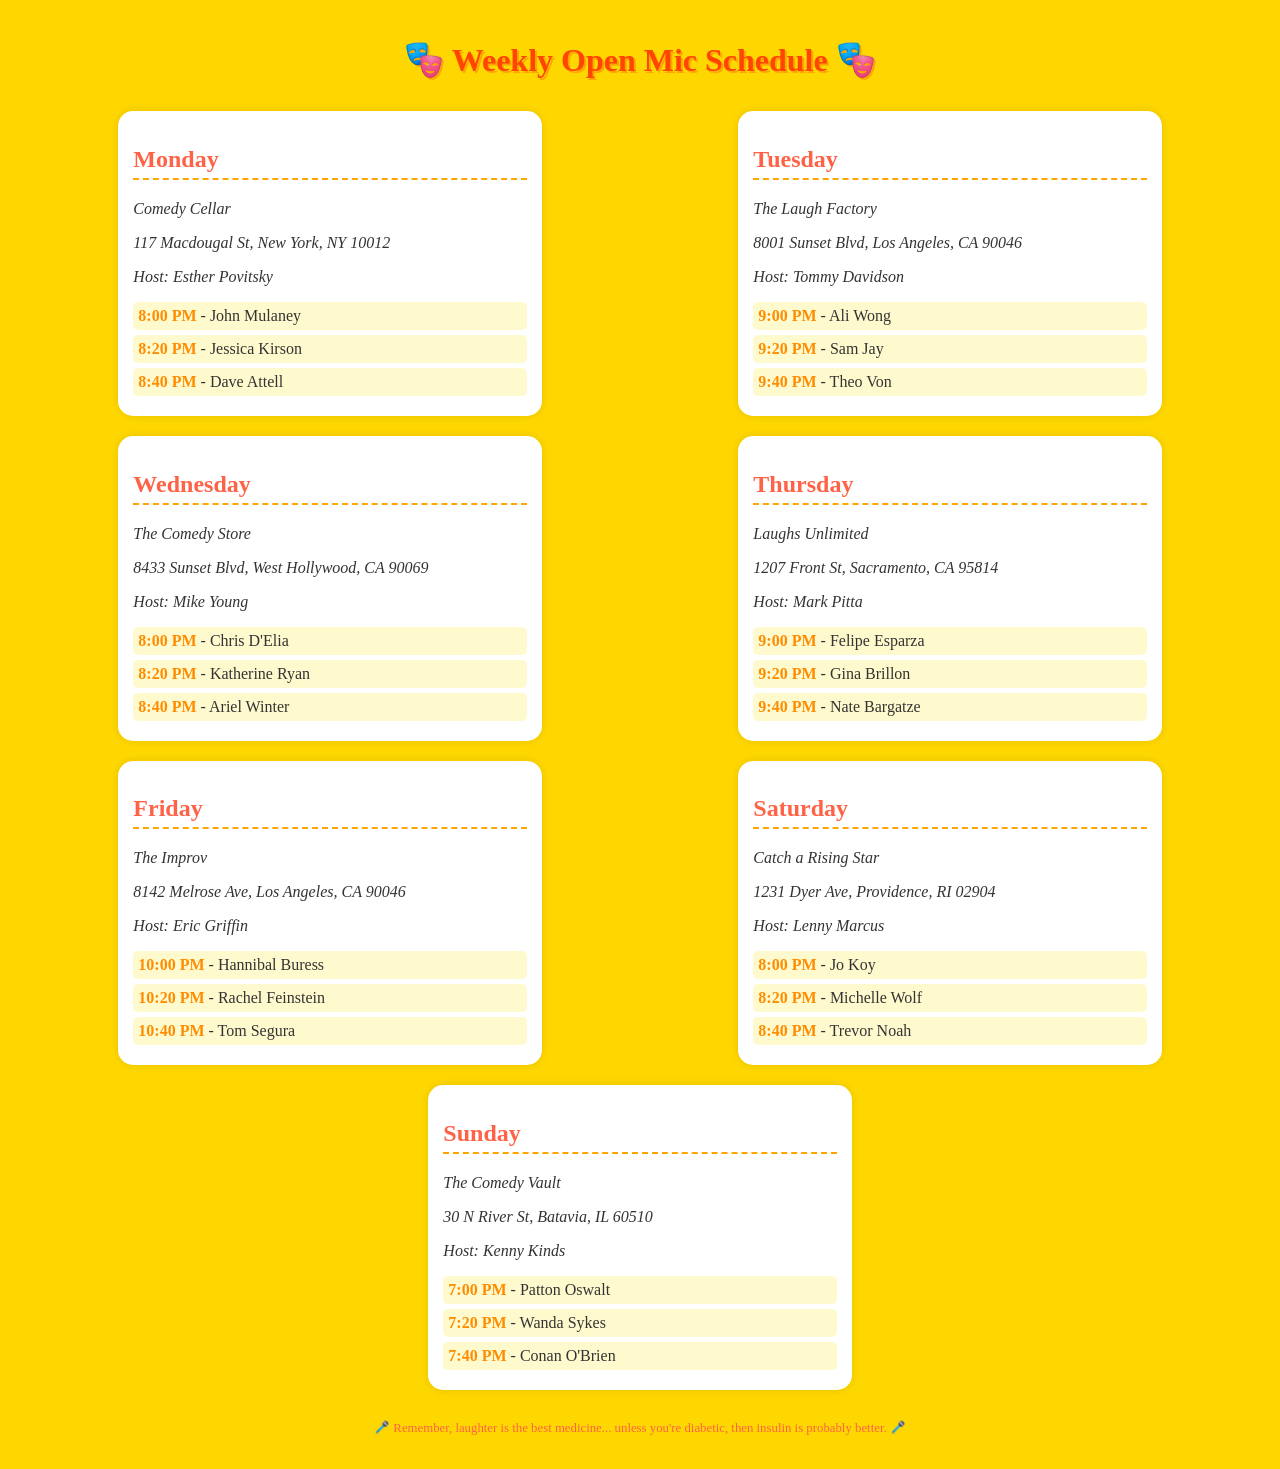What venue hosts open mic on Monday? The venue hosting open mic on Monday is listed in the schedule.
Answer: Comedy Cellar Who is the host at The Laugh Factory? The host's name is specified in the information for The Laugh Factory on Tuesday.
Answer: Tommy Davidson What time does the open mic start on Saturday? The starting time for the Saturday open mic is provided in the document.
Answer: 8:00 PM Which performer is scheduled at 9:40 PM on Thursday? This performer’s name can be found next to their scheduled time for Thursday in the document.
Answer: Nate Bargatze How many performers are listed for Friday? The number of performers scheduled for Friday can be counted from the document.
Answer: 3 